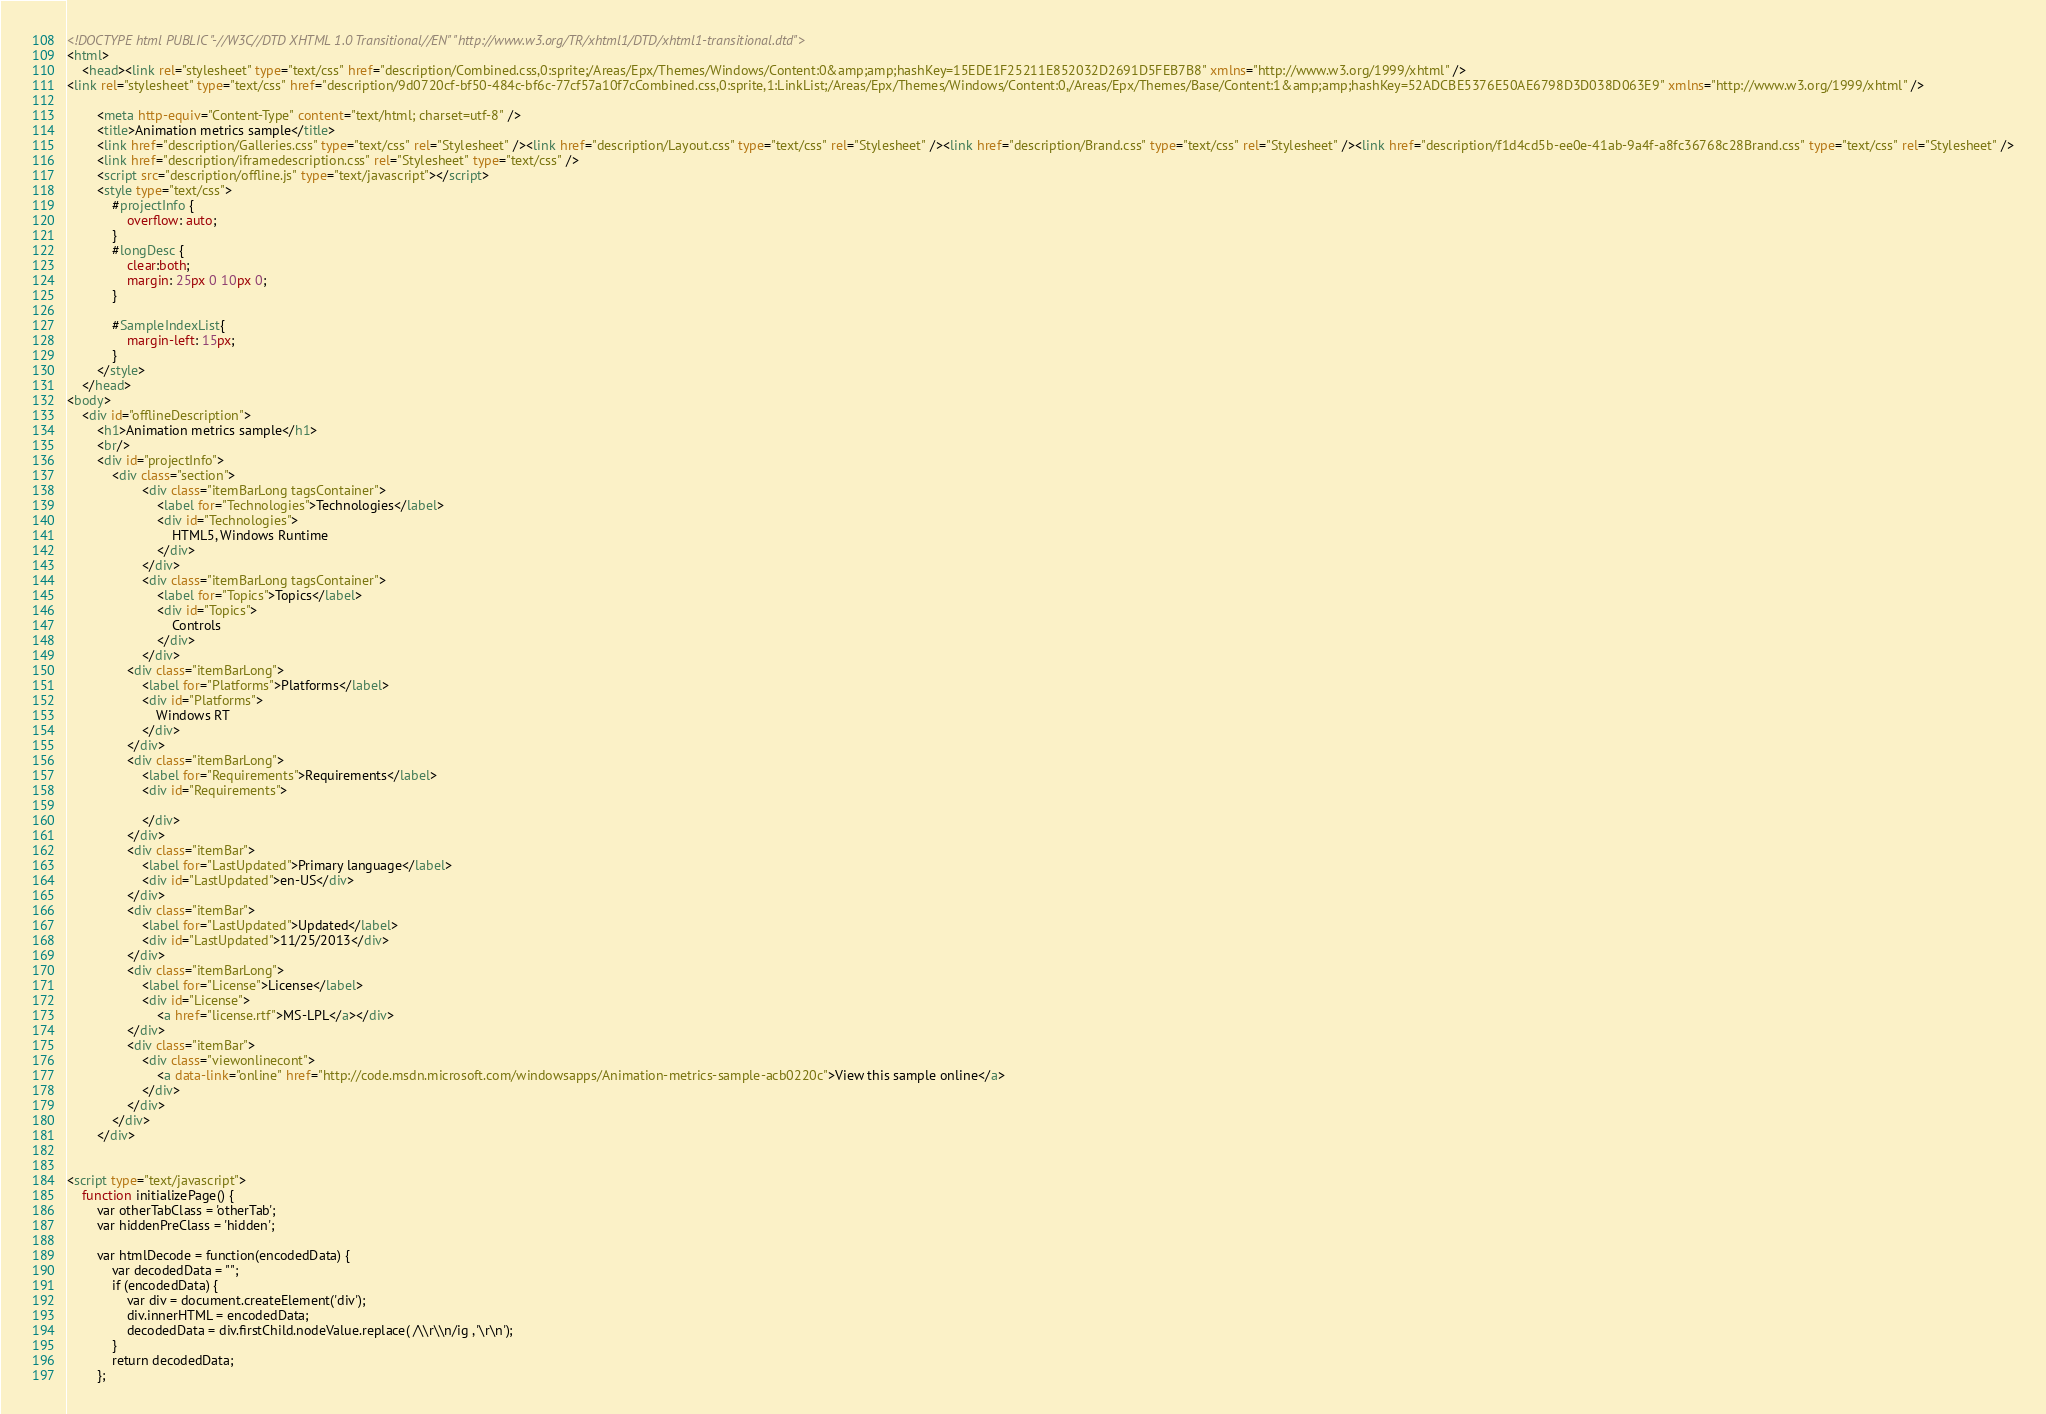<code> <loc_0><loc_0><loc_500><loc_500><_HTML_><!DOCTYPE html PUBLIC "-//W3C//DTD XHTML 1.0 Transitional//EN" "http://www.w3.org/TR/xhtml1/DTD/xhtml1-transitional.dtd">
<html>
    <head><link rel="stylesheet" type="text/css" href="description/Combined.css,0:sprite;/Areas/Epx/Themes/Windows/Content:0&amp;amp;hashKey=15EDE1F25211E852032D2691D5FEB7B8" xmlns="http://www.w3.org/1999/xhtml" />
<link rel="stylesheet" type="text/css" href="description/9d0720cf-bf50-484c-bf6c-77cf57a10f7cCombined.css,0:sprite,1:LinkList;/Areas/Epx/Themes/Windows/Content:0,/Areas/Epx/Themes/Base/Content:1&amp;amp;hashKey=52ADCBE5376E50AE6798D3D038D063E9" xmlns="http://www.w3.org/1999/xhtml" />

        <meta http-equiv="Content-Type" content="text/html; charset=utf-8" />
        <title>Animation metrics sample</title>
        <link href="description/Galleries.css" type="text/css" rel="Stylesheet" /><link href="description/Layout.css" type="text/css" rel="Stylesheet" /><link href="description/Brand.css" type="text/css" rel="Stylesheet" /><link href="description/f1d4cd5b-ee0e-41ab-9a4f-a8fc36768c28Brand.css" type="text/css" rel="Stylesheet" />
        <link href="description/iframedescription.css" rel="Stylesheet" type="text/css" />
        <script src="description/offline.js" type="text/javascript"></script>
        <style type="text/css">
            #projectInfo {
                overflow: auto;
            }
            #longDesc {
                clear:both;
                margin: 25px 0 10px 0;
            }

            #SampleIndexList{
                margin-left: 15px;
            }
        </style>
    </head>
<body>
    <div id="offlineDescription">
        <h1>Animation metrics sample</h1>
        <br/>
        <div id="projectInfo">
            <div class="section">
                    <div class="itemBarLong tagsContainer">
                        <label for="Technologies">Technologies</label>
                        <div id="Technologies">
                            HTML5, Windows Runtime
                        </div>
                    </div>
                    <div class="itemBarLong tagsContainer">
                        <label for="Topics">Topics</label>
                        <div id="Topics">
                            Controls
                        </div>
                    </div>
                <div class="itemBarLong">
                    <label for="Platforms">Platforms</label>
                    <div id="Platforms">
                        Windows RT
                    </div>
                </div>
                <div class="itemBarLong">
                    <label for="Requirements">Requirements</label>
                    <div id="Requirements">
                        
                    </div>
                </div>
                <div class="itemBar">
                    <label for="LastUpdated">Primary language</label>
                    <div id="LastUpdated">en-US</div>
                </div>
                <div class="itemBar">
                    <label for="LastUpdated">Updated</label>
                    <div id="LastUpdated">11/25/2013</div>
                </div>
                <div class="itemBarLong">
                    <label for="License">License</label>
                    <div id="License">
                        <a href="license.rtf">MS-LPL</a></div>
                </div>
                <div class="itemBar">
                    <div class="viewonlinecont">
                        <a data-link="online" href="http://code.msdn.microsoft.com/windowsapps/Animation-metrics-sample-acb0220c">View this sample online</a>
                    </div>
                </div>
            </div>
        </div>
        
                   
<script type="text/javascript">
    function initializePage() {
        var otherTabClass = 'otherTab';
        var hiddenPreClass = 'hidden';

        var htmlDecode = function(encodedData) {
            var decodedData = "";
            if (encodedData) {
                var div = document.createElement('div');
                div.innerHTML = encodedData;
                decodedData = div.firstChild.nodeValue.replace( /\\r\\n/ig , '\r\n');
            }
            return decodedData;
        };</code> 